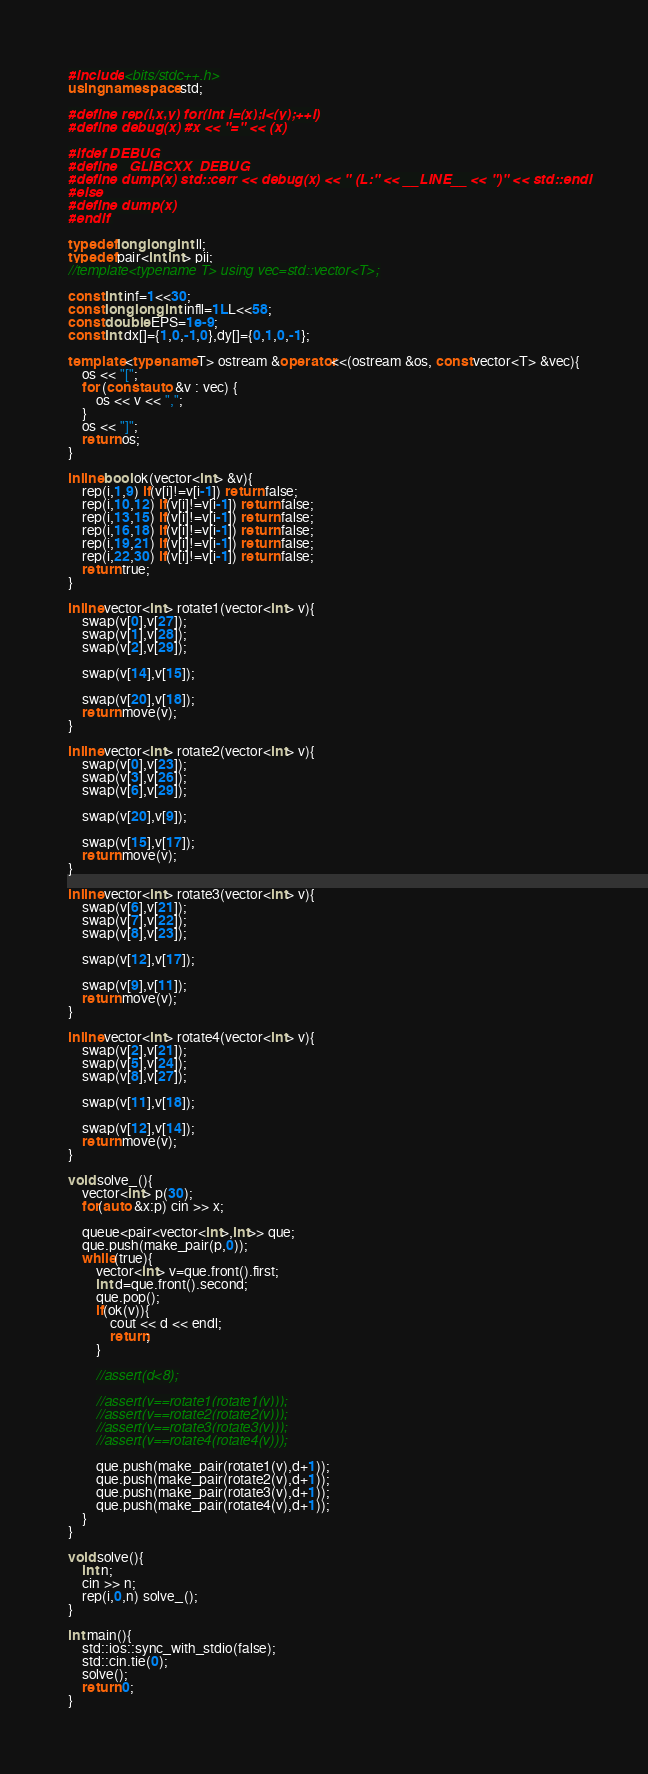<code> <loc_0><loc_0><loc_500><loc_500><_C++_>#include <bits/stdc++.h>
using namespace std;

#define rep(i,x,y) for(int i=(x);i<(y);++i)
#define debug(x) #x << "=" << (x)
 
#ifdef DEBUG
#define _GLIBCXX_DEBUG
#define dump(x) std::cerr << debug(x) << " (L:" << __LINE__ << ")" << std::endl
#else
#define dump(x)
#endif

typedef long long int ll;
typedef pair<int,int> pii;
//template<typename T> using vec=std::vector<T>;

const int inf=1<<30;
const long long int infll=1LL<<58;
const double EPS=1e-9;
const int dx[]={1,0,-1,0},dy[]={0,1,0,-1};

template <typename T> ostream &operator<<(ostream &os, const vector<T> &vec){
	os << "[";
	for (const auto &v : vec) {
		os << v << ",";
	}
	os << "]";
	return os;
}

inline bool ok(vector<int> &v){
    rep(i,1,9) if(v[i]!=v[i-1]) return false;
    rep(i,10,12) if(v[i]!=v[i-1]) return false;
    rep(i,13,15) if(v[i]!=v[i-1]) return false;
    rep(i,16,18) if(v[i]!=v[i-1]) return false;
    rep(i,19,21) if(v[i]!=v[i-1]) return false;
    rep(i,22,30) if(v[i]!=v[i-1]) return false;
    return true;
}

inline vector<int> rotate1(vector<int> v){
    swap(v[0],v[27]);
    swap(v[1],v[28]);
    swap(v[2],v[29]);
    
    swap(v[14],v[15]);
    
    swap(v[20],v[18]);
    return move(v);
}

inline vector<int> rotate2(vector<int> v){
    swap(v[0],v[23]);
    swap(v[3],v[26]);
    swap(v[6],v[29]);
    
    swap(v[20],v[9]);
    
    swap(v[15],v[17]);
    return move(v);
}

inline vector<int> rotate3(vector<int> v){
    swap(v[6],v[21]);
    swap(v[7],v[22]);
    swap(v[8],v[23]);
    
    swap(v[12],v[17]);
    
    swap(v[9],v[11]);
    return move(v);
}

inline vector<int> rotate4(vector<int> v){
    swap(v[2],v[21]);
    swap(v[5],v[24]);
    swap(v[8],v[27]);
    
    swap(v[11],v[18]);
    
    swap(v[12],v[14]);
    return move(v);
}

void solve_(){
    vector<int> p(30);
    for(auto &x:p) cin >> x;
    
    queue<pair<vector<int>,int>> que;
    que.push(make_pair(p,0));
    while(true){
        vector<int> v=que.front().first;
        int d=que.front().second;
        que.pop();
        if(ok(v)){
            cout << d << endl;
            return;
        }
        
        //assert(d<8);
        
        //assert(v==rotate1(rotate1(v)));
        //assert(v==rotate2(rotate2(v)));
        //assert(v==rotate3(rotate3(v)));
        //assert(v==rotate4(rotate4(v)));
        
        que.push(make_pair(rotate1(v),d+1));
        que.push(make_pair(rotate2(v),d+1));
        que.push(make_pair(rotate3(v),d+1));
        que.push(make_pair(rotate4(v),d+1));
    }
}

void solve(){
    int n;
    cin >> n;
    rep(i,0,n) solve_();
}

int main(){
	std::ios::sync_with_stdio(false);
	std::cin.tie(0);
	solve();
	return 0;
}</code> 